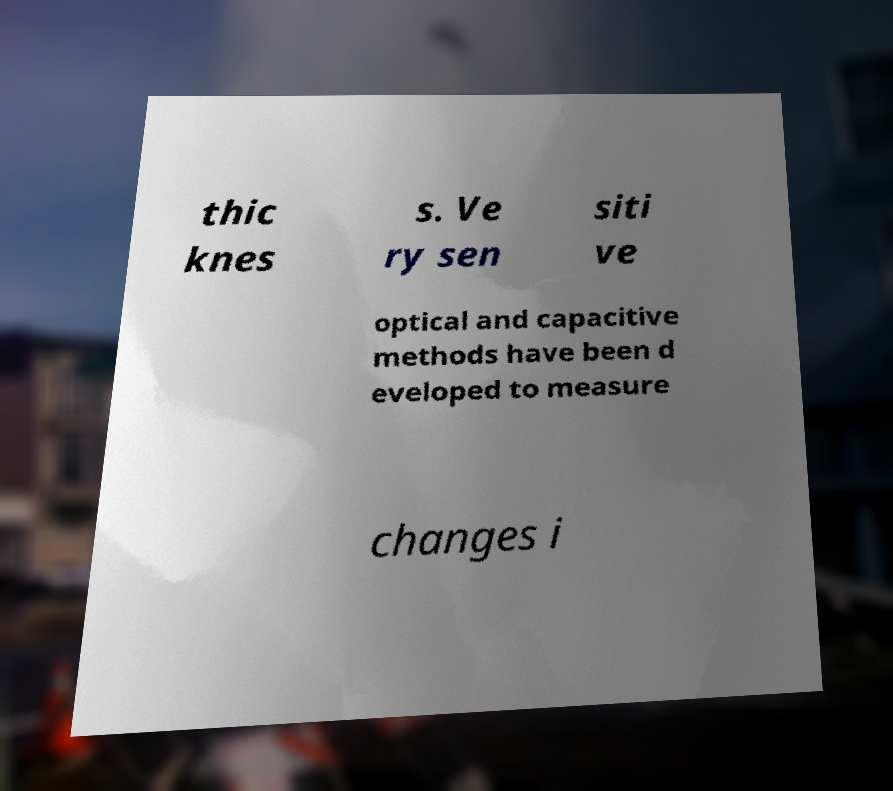What messages or text are displayed in this image? I need them in a readable, typed format. thic knes s. Ve ry sen siti ve optical and capacitive methods have been d eveloped to measure changes i 